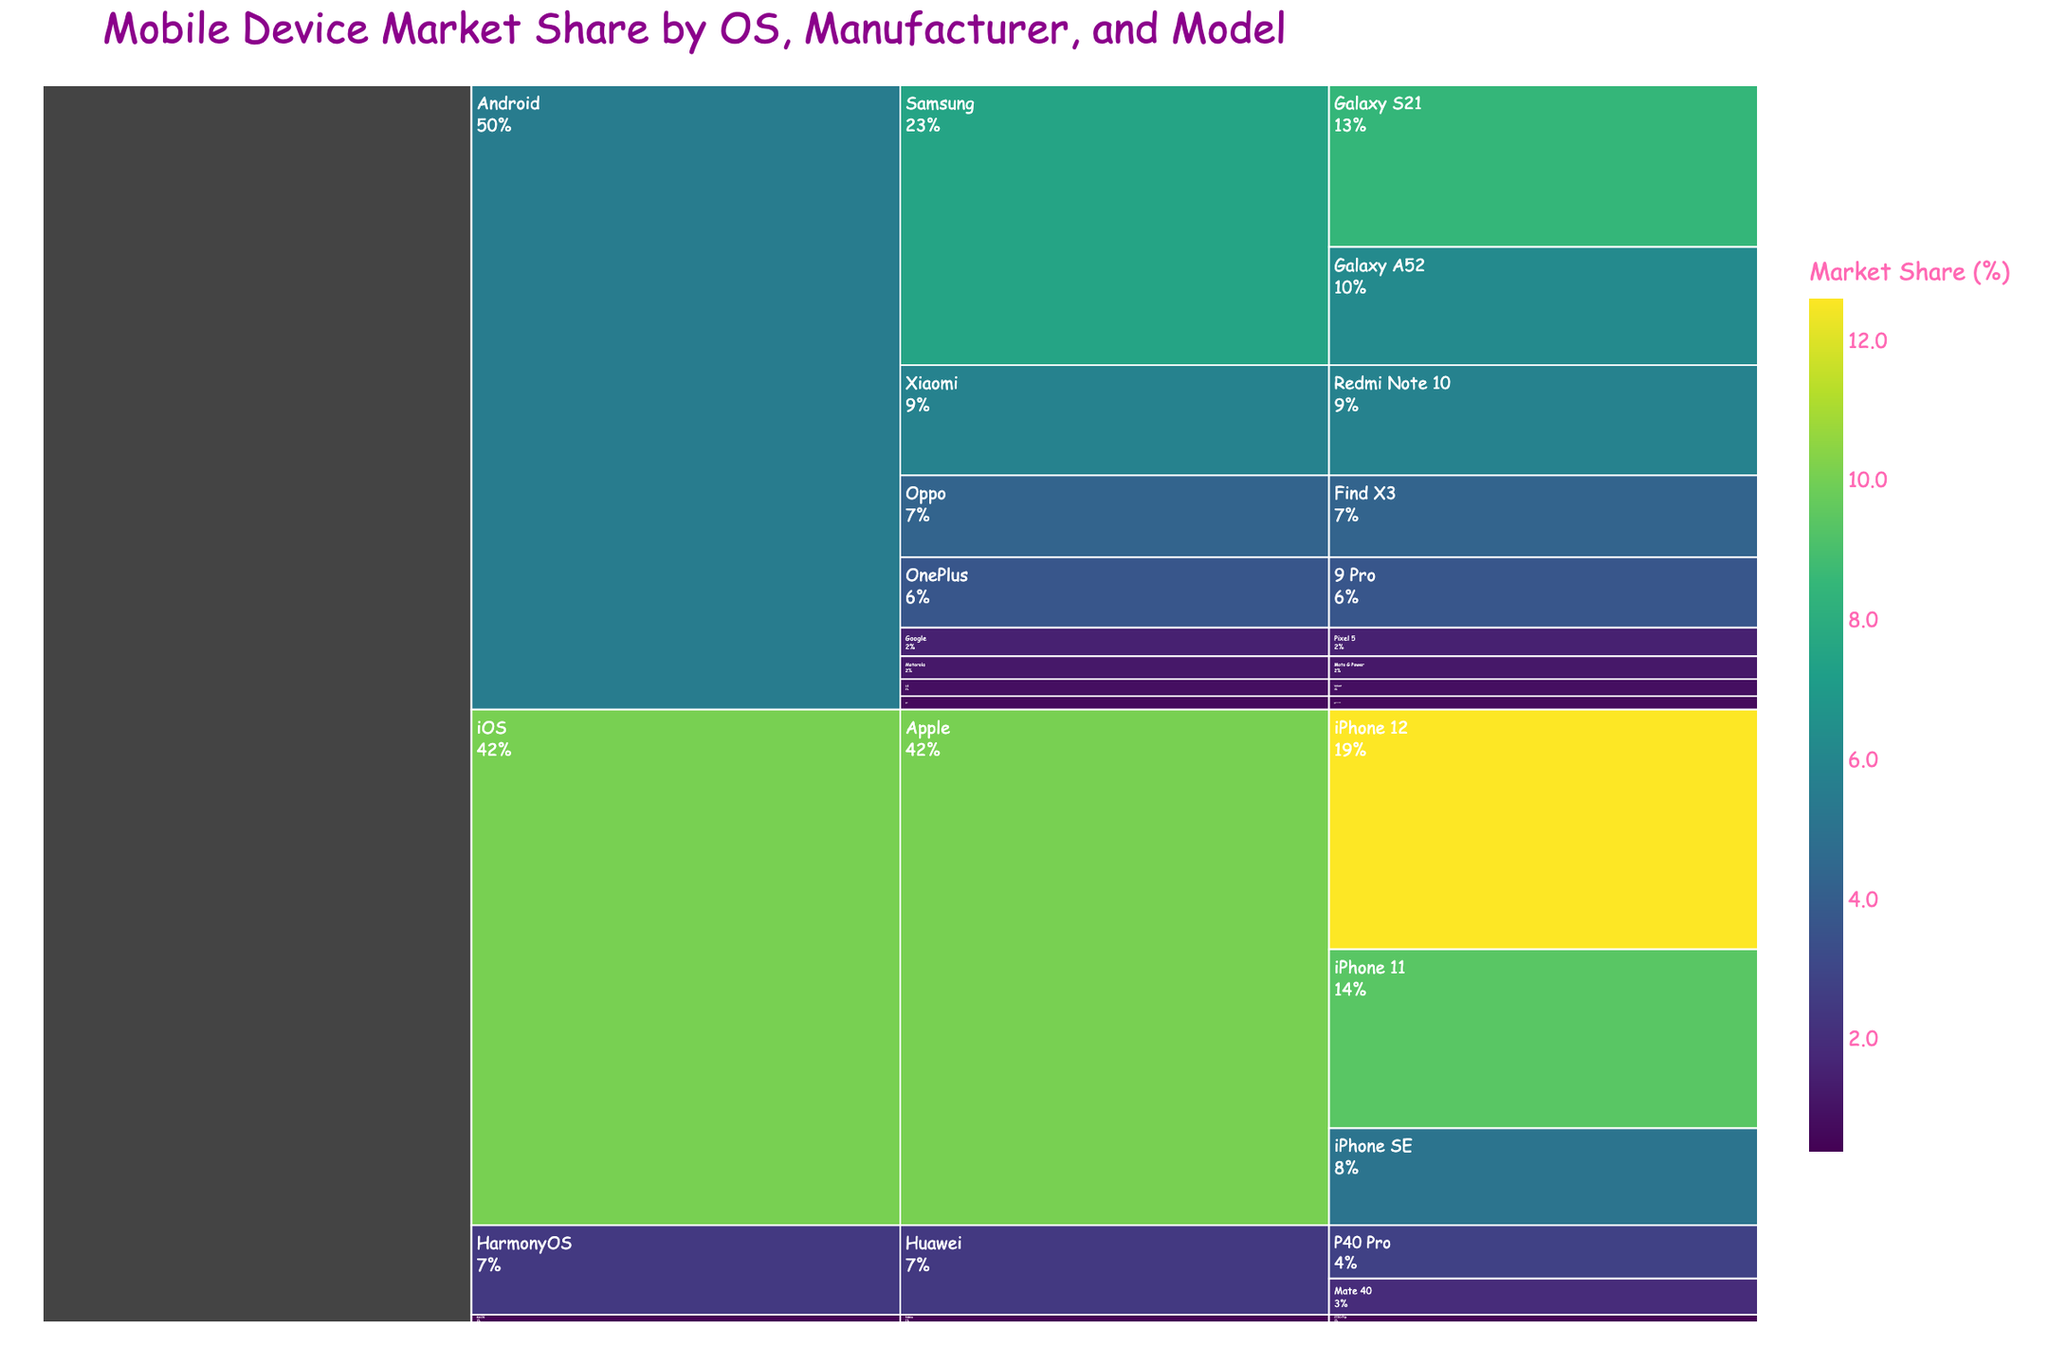what is the title of the figure? The title of the figure is the largest text at the top, usually summarizing what the plot represents. In this case, it is written in a prominent font. The title is "Mobile Device Market Share by OS, Manufacturer, and Model".
Answer: Mobile Device Market Share by OS, Manufacturer, and Model Which operating system has the highest market share for a single model? To find the operating system with the highest market share, identify the largest individual segment within the "Operating System" level of the icicle chart. The largest segment is iOS with the iPhone 12 having a 12.6% market share.
Answer: iOS How does the market share of the Samsung Galaxy S21 compare to that of the Apple iPhone 12? To compare the market share, look at the segments for Samsung Galaxy S21 and Apple iPhone 12. The Samsung Galaxy S21 has an 8.5% share, while the Apple iPhone 12 has a 12.6% share. Clearly, the iPhone 12 has a higher market share than the Galaxy S21.
Answer: Apple iPhone 12 has a higher market share What's the total market share of Huawei devices running HarmonyOS? To find the total market share for Huawei devices, sum the shares of Huawei P40 Pro and Huawei Mate 40. Huawei P40 Pro has a 2.8% share and Huawei Mate 40 has a 1.9% share. Therefore, the total is 2.8% + 1.9% = 4.7%.
Answer: 4.7% Which manufacturer has the least market share under the Android operating system? Check the segments under the Android operating system and identify the manufacturer with the smallest market share. The manufacturers are Samsung, Xiaomi, Oppo, OnePlus, Google, Motorola, LG, and Sony. Sony has the smallest segment with a 0.7% market share.
Answer: Sony What's the combined market share of the top three Android models? Identify the top three Android models in terms of market share: Samsung Galaxy S21 (8.5%), Samsung Galaxy A52 (6.2%), and Xiaomi Redmi Note 10 (5.8%). Add their market shares: 8.5% + 6.2% + 5.8% = 20.5%.
Answer: 20.5% What percentage do operating systems other than Android contribute to the total market share? Find the market shares for iOS, HarmonyOS, and KaiOS. iOS has (12.6 + 9.4 + 5.1 = 27.1%), HarmonyOS has (2.8 + 1.9 = 4.7%), and KaiOS has 0.4%. Therefore, total is 27.1 + 4.7 + 0.4 = 32.2%.
Answer: 32.2% What's the total market share for Apple devices? Check the segments under iOS for Apple devices: iPhone 12 (12.6%), iPhone 11 (9.4%), and iPhone SE (5.1%). Sum their market shares: 12.6 + 9.4 + 5.1 = 27.1%.
Answer: 27.1% Which model has a higher market share: OnePlus 9 Pro or Google Pixel 5? Compare the segments representing OnePlus 9 Pro and Google Pixel 5. OnePlus 9 Pro has a 3.7% market share, while Google Pixel 5 has a 1.5% market share. OnePlus 9 Pro has a higher market share than Google Pixel 5.
Answer: OnePlus 9 Pro Can you find the market share for the least popular mobile model? Identify the segment with the smallest market share across all operating systems and manufacturers. The smallest share is for the Nokia 2720 Flip with a 0.4% share.
Answer: Nokia 2720 Flip, 0.4% 